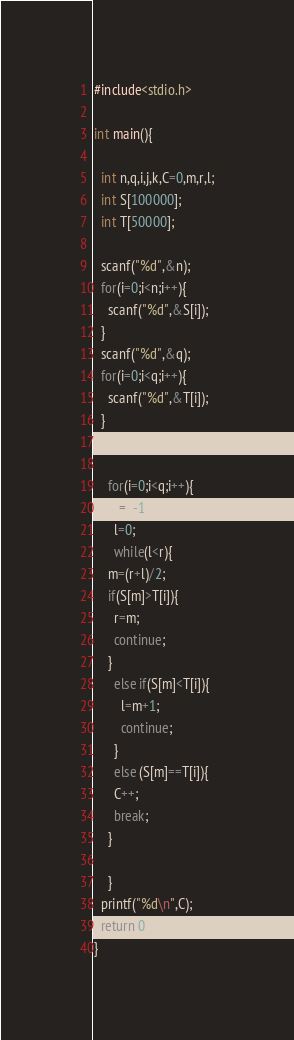<code> <loc_0><loc_0><loc_500><loc_500><_C_>#include<stdio.h>

int main(){

  int n,q,i,j,k,C=0,m,r,l;
  int S[100000];
  int T[50000];

  scanf("%d",&n);
  for(i=0;i<n;i++){
    scanf("%d",&S[i]);
  }
  scanf("%d",&q);
  for(i=0;i<q;i++){
    scanf("%d",&T[i]);
  }


    for(i=0;i<q;i++){
      r=n-1;
      l=0;
      while(l<r){
	m=(r+l)/2;
	if(S[m]>T[i]){ 
	  r=m;
	  continue;
	}
	  else if(S[m]<T[i]){
	    l=m+1;
	    continue;
	  }
	  else (S[m]==T[i]){
	  C++;
	  break;
	}
	
    }	
  printf("%d\n",C);
  return 0;
}

</code> 